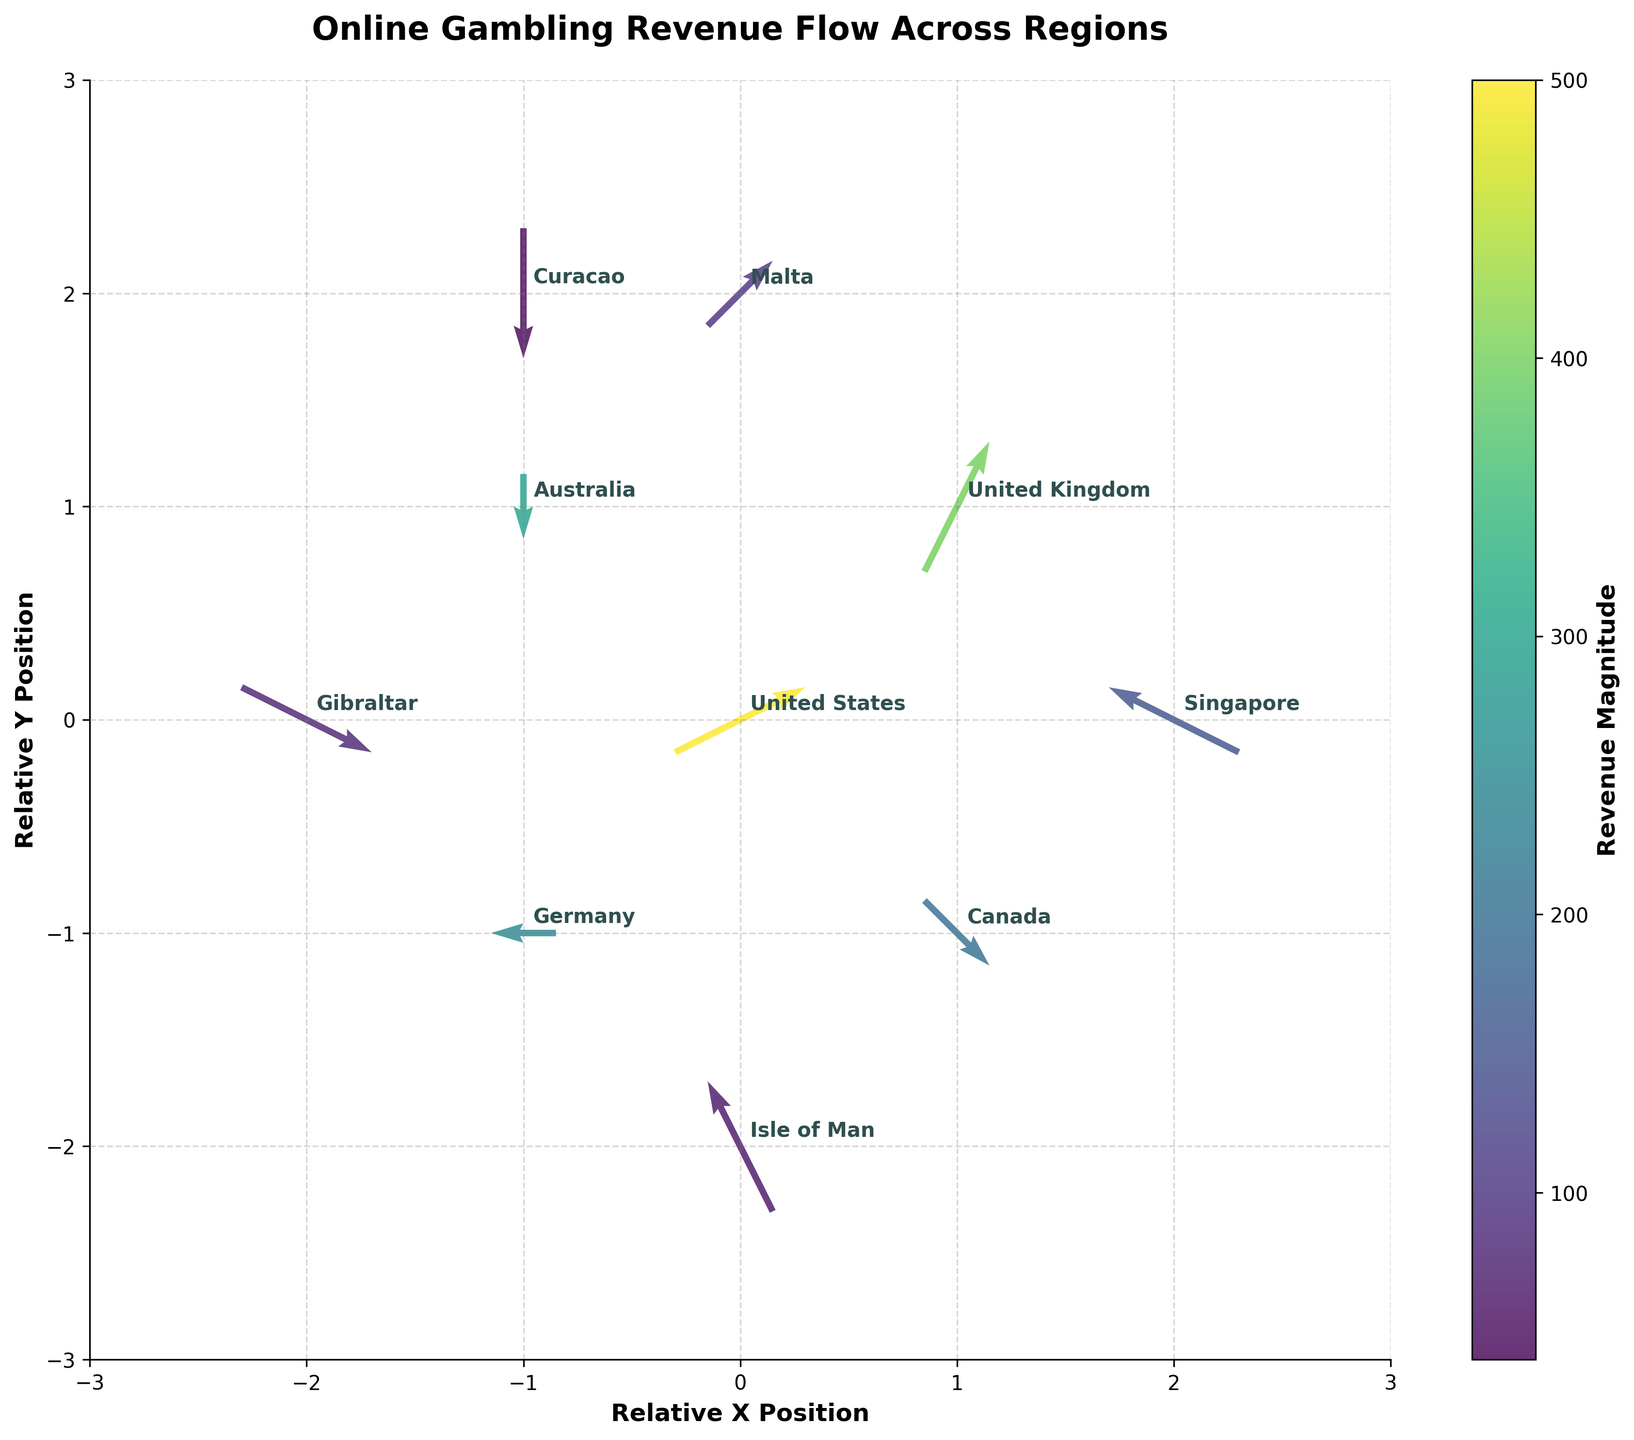what is the title of the plot? The title of the plot is usually found at the top center of the figure. For this plot, it reads 'Online Gambling Revenue Flow Across Regions’.
Answer: Online Gambling Revenue Flow Across Regions how many unique regions are represented in the plot? To determine the number of unique regions represented in the plot, count the distinct region labels annotated near each point in the plot.
Answer: 10 what does the color of the arrows represent? The color of the arrows is determined by the revenue magnitude, as indicated in the color bar on the right side of the plot. Darker colors represent higher revenue magnitudes.
Answer: revenue magnitude which region has the highest revenue magnitude? Locate the region with the darkest colored arrow pointing from it. The regions with higher revenue magnitudes will have arrows with colors closer to the darker end of the color bar.
Answer: United States which region's revenue flow is directed towards the negative X-axis and positive Y-axis? Check the direction of the arrows from the region labels and find the one pointing towards the negative X-axis (left) and positive Y-axis (upwards).
Answer: Isle of Man which regions have a revenue flow in the positive X direction? Identify the arrows pointing towards the positive X direction (right), then look at the region labels attached to those arrows.
Answer: United States, United Kingdom, Malta, Gibraltar, Canada which region has the smallest revenue magnitude? Look for the region with the lightest colored arrow pointing from it as lighter colors represent smaller revenue magnitudes.
Answer: Curacao how does the revenue flow of the United Kingdom compare to that of Germany in terms of direction and magnitude? Compare the arrows starting from the United Kingdom and Germany. The arrow from the United Kingdom points upwards and to the right, while the one from Germany points to the left. The United Kingdom has a higher magnitude as indicated by the darker color.
Answer: United Kingdom flows up and right, Germany left, United Kingdom higher which regions have revenue flows with both positive or both negative X and Y components? Identify arrows that point either both up and right or both down and left by examining their X and Y direction components.
Answer: Malta, Isle of Man what quadrants in the plot do the majority of the arrows fall into? Visually inspect the quadrants (top-left, top-right, bottom-left, bottom-right) to see where most arrows are positioned. Note the regions in each quadrant by their component directions.
Answer: first and second quadrants 